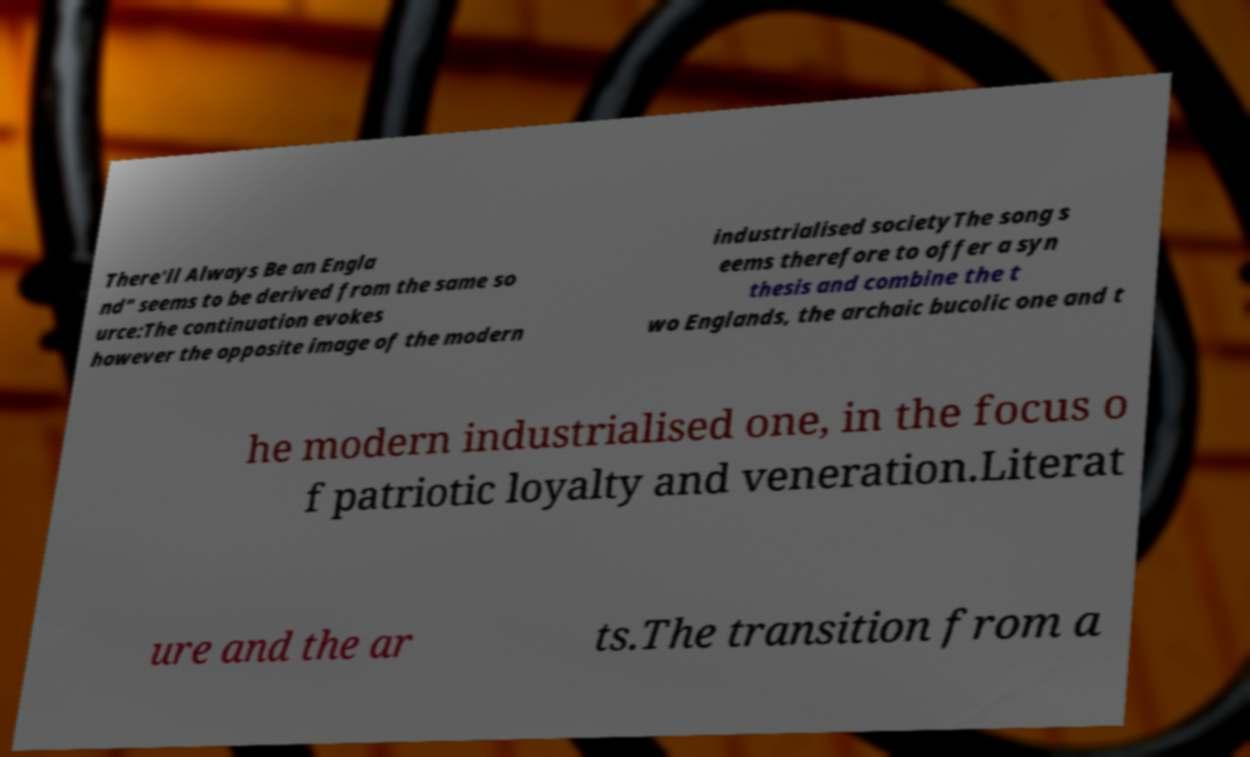Can you accurately transcribe the text from the provided image for me? There'll Always Be an Engla nd" seems to be derived from the same so urce:The continuation evokes however the opposite image of the modern industrialised societyThe song s eems therefore to offer a syn thesis and combine the t wo Englands, the archaic bucolic one and t he modern industrialised one, in the focus o f patriotic loyalty and veneration.Literat ure and the ar ts.The transition from a 